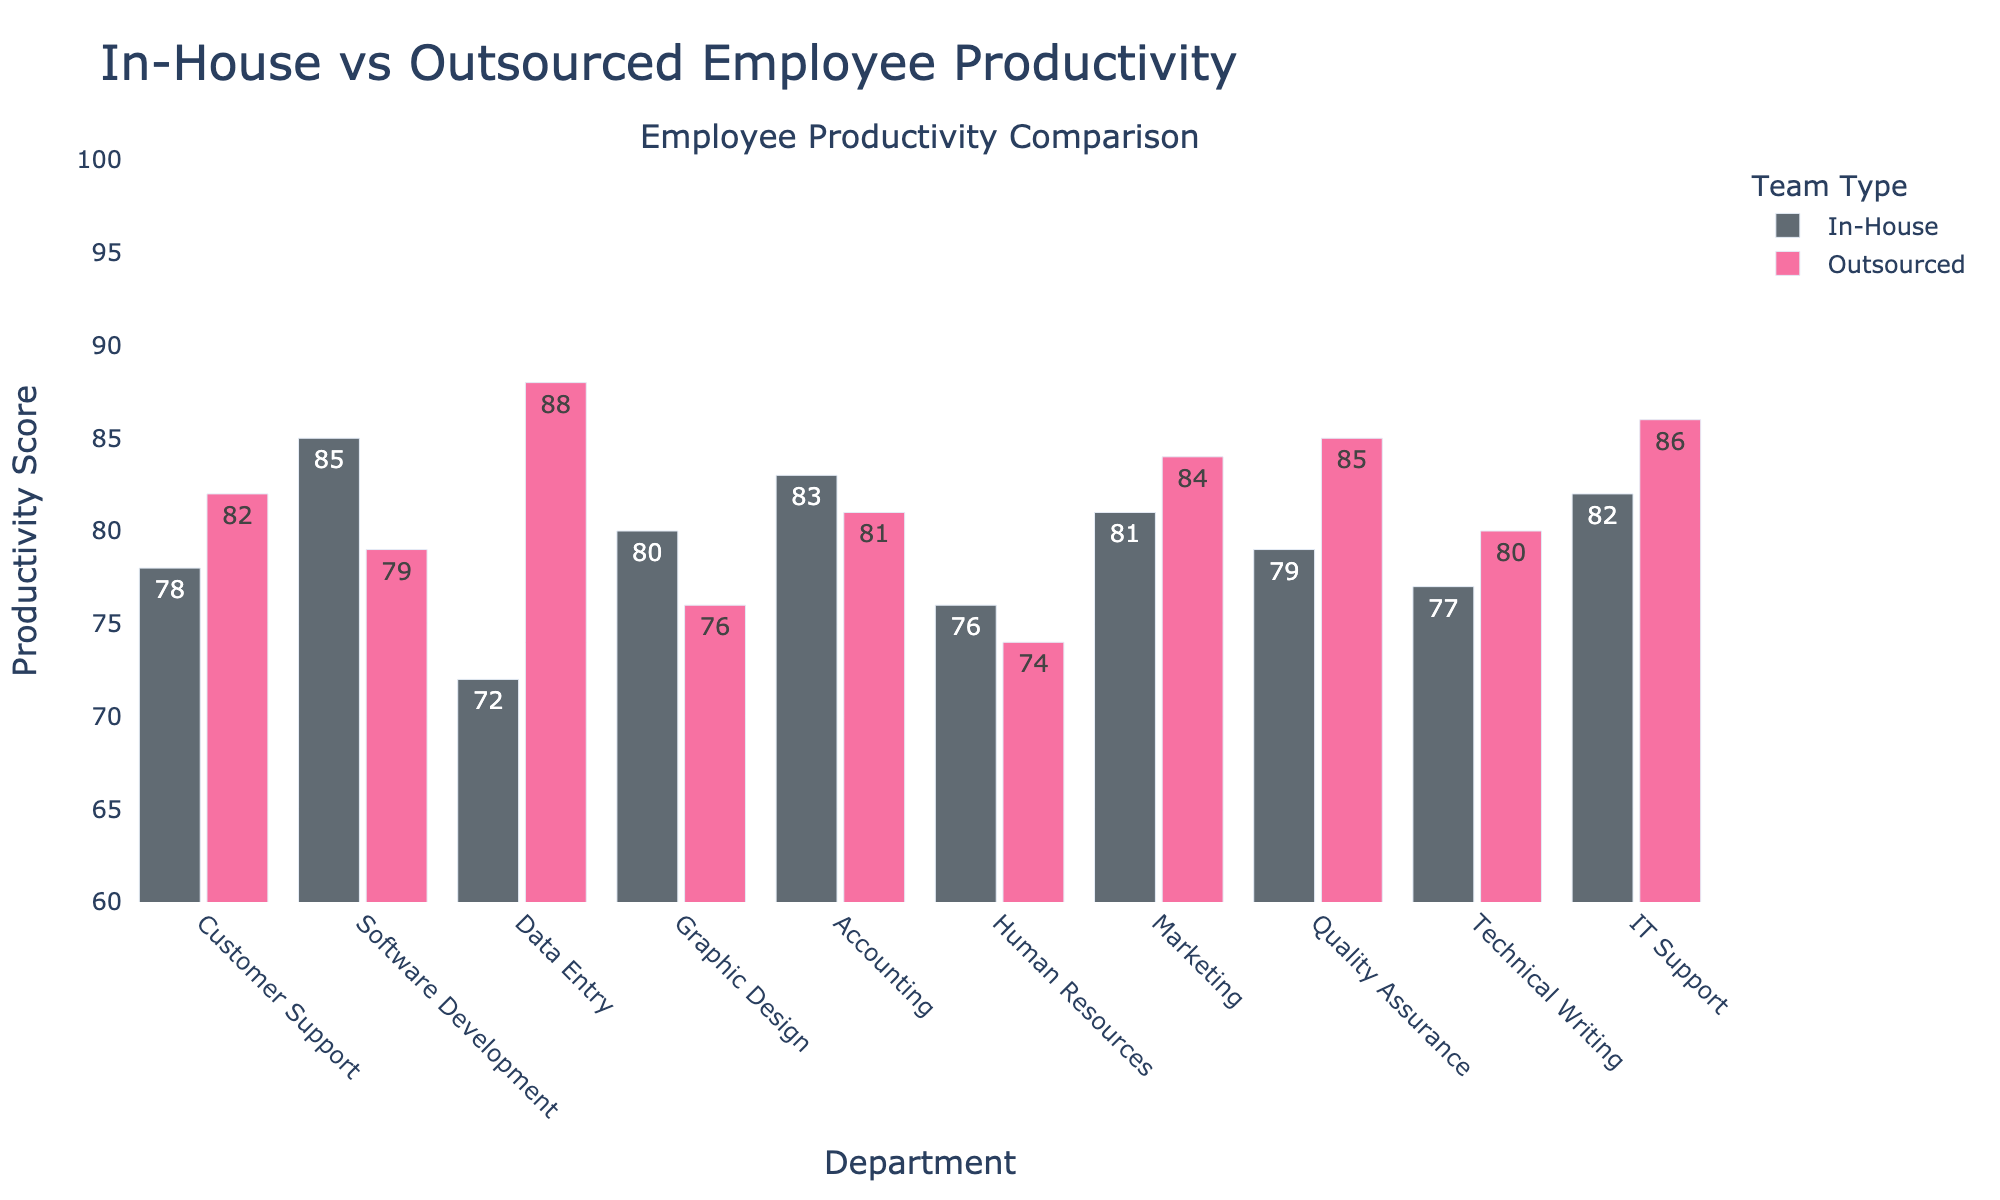What is the difference in productivity between In-House and Outsourced teams in the Customer Support department? In the Customer Support department, the In-House productivity is 78, and the Outsourced productivity is 82. The difference is calculated by subtracting the In-House value from the Outsourced value: 82 - 78.
Answer: 4 Which department has the highest Outsourced productivity? To determine the department with the highest Outsourced productivity, we compare the values for each department. The highest is 88, found in the Data Entry department.
Answer: Data Entry In how many departments is the Outsourced productivity higher than the In-House productivity? Compare the productivity values for In-House and Outsourced in each department. Outsourced productivity is higher in Customer Support, Data Entry, Marketing, Quality Assurance, Technical Writing, and IT Support. This occurs in 6 departments.
Answer: 6 Which department shows the greatest productivity difference between In-House and Outsourced teams, and what is that difference? Calculate the difference for each department: Customer Support (4), Software Development (6), Data Entry (16), Graphic Design (4), Accounting (2), Human Resources (2), Marketing (3), Quality Assurance (6), Technical Writing (3), and IT Support (4). The greatest difference is found in the Data Entry department, with a difference of 16.
Answer: Data Entry, 16 What is the average productivity score for the In-House teams across all departments? Sum up the In-House productivity values (78 + 85 + 72 + 80 + 83 + 76 + 81 + 79 + 77 + 82) to get 793. Then divide by the number of departments (10): 793 / 10.
Answer: 79.3 Which team, In-House or Outsourced, has a higher average productivity score across all departments? First, find the total productivity scores for each team: In-House (793) and Outsourced (815). Then calculate the average for each team by dividing by the number of departments (10): In-House (793 / 10 = 79.3) and Outsourced (815 / 10 = 81.5). Compare the two averages. Outsourced has a higher average productivity.
Answer: Outsourced If the productivity scores of the In-House and Outsourced teams are combined for each department, which department has the highest total? Sum the productivity scores for each department: 
Customer Support (78 + 82 = 160), 
Software Development (85 + 79 = 164), 
Data Entry (72 + 88 = 160), 
Graphic Design (80 + 76 = 156), 
Accounting (83 + 81 = 164), 
Human Resources (76 + 74 = 150), 
Marketing (81 + 84 = 165), 
Quality Assurance (79 + 85 = 164), 
Technical Writing (77 + 80 = 157), 
IT Support (82 + 86 = 168). 
The highest total is 168, found in IT Support.
Answer: IT Support Which two departments have the smallest difference in productivity between In-House and Outsourced teams? Calculate the differences for all departments: Customer Support (4), Software Development (6), Data Entry (16), Graphic Design (4), Accounting (2), Human Resources (2), Marketing (3), Quality Assurance (6), Technical Writing (3), and IT Support (4). The two smallest differences are in Accounting and Human Resources, both with a difference of 2.
Answer: Accounting, Human Resources 